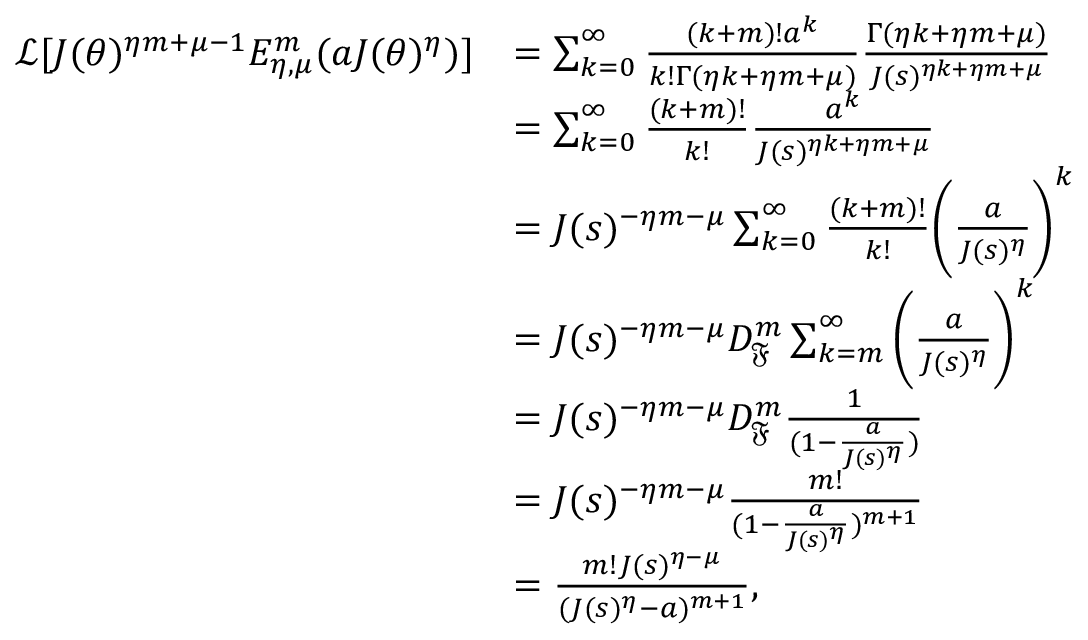Convert formula to latex. <formula><loc_0><loc_0><loc_500><loc_500>\begin{array} { r l } { \mathcal { L } [ J ( \theta ) ^ { \eta m + \mu - 1 } E _ { \eta , \mu } ^ { m } ( a J ( \theta ) ^ { \eta } ) ] } & { = \sum _ { k = 0 } ^ { \infty } \frac { ( k + m ) ! a ^ { k } } { k ! \Gamma ( \eta k + \eta m + \mu ) } \frac { \Gamma ( \eta k + \eta m + \mu ) } { J ( s ) ^ { \eta k + \eta m + \mu } } } \\ & { = \sum _ { k = 0 } ^ { \infty } \frac { ( k + m ) ! } { k ! } \frac { a ^ { k } } { J ( s ) ^ { \eta k + \eta m + \mu } } } \\ & { = J ( s ) ^ { - \eta m - \mu } \sum _ { k = 0 } ^ { \infty } \frac { ( k + m ) ! } { k ! } \left ( \frac { a } { J ( s ) ^ { \eta } } \right ) ^ { k } } \\ & { = J ( s ) ^ { - \eta m - \mu } D _ { \mathfrak { F } } ^ { m } \sum _ { k = m } ^ { \infty } \left ( \frac { a } { J ( s ) ^ { \eta } } \right ) ^ { k } } \\ & { = J ( s ) ^ { - \eta m - \mu } D _ { \mathfrak { F } } ^ { m } \frac { 1 } { ( 1 - \frac { a } { J ( s ) ^ { \eta } } ) } } \\ & { = J ( s ) ^ { - \eta m - \mu } \frac { m ! } { ( 1 - \frac { a } { J ( s ) ^ { \eta } } ) ^ { m + 1 } } } \\ & { = \frac { m ! J ( s ) ^ { \eta - \mu } } { ( J ( s ) ^ { \eta } - a ) ^ { m + 1 } } , } \end{array}</formula> 